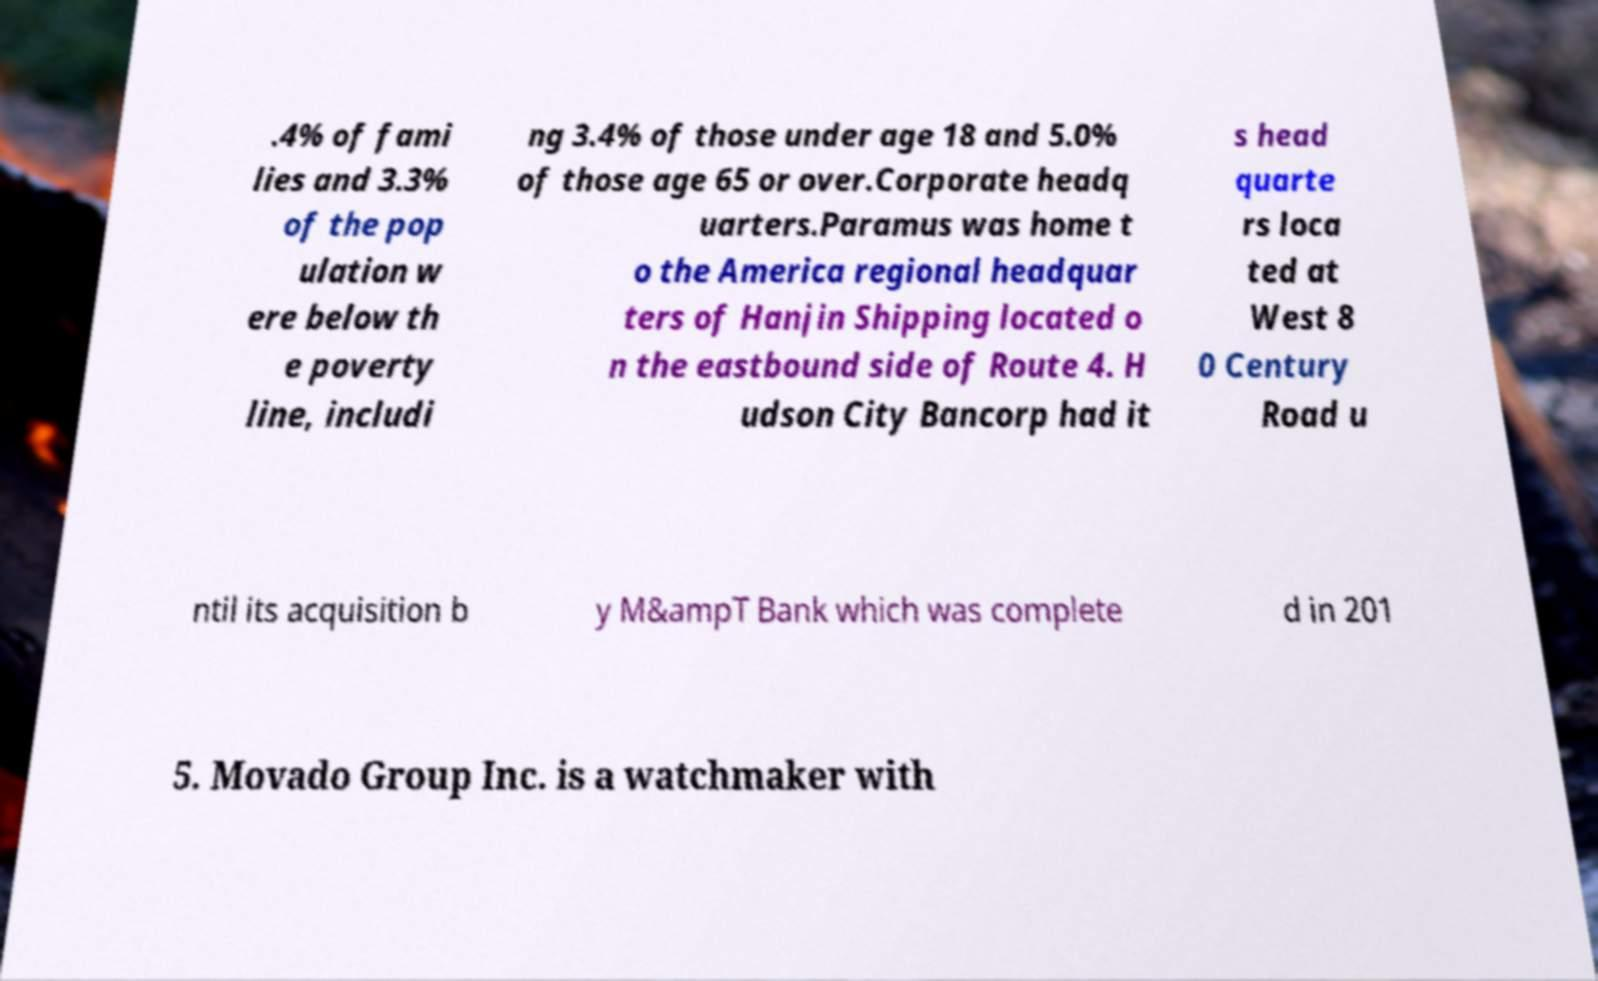Could you extract and type out the text from this image? .4% of fami lies and 3.3% of the pop ulation w ere below th e poverty line, includi ng 3.4% of those under age 18 and 5.0% of those age 65 or over.Corporate headq uarters.Paramus was home t o the America regional headquar ters of Hanjin Shipping located o n the eastbound side of Route 4. H udson City Bancorp had it s head quarte rs loca ted at West 8 0 Century Road u ntil its acquisition b y M&ampT Bank which was complete d in 201 5. Movado Group Inc. is a watchmaker with 